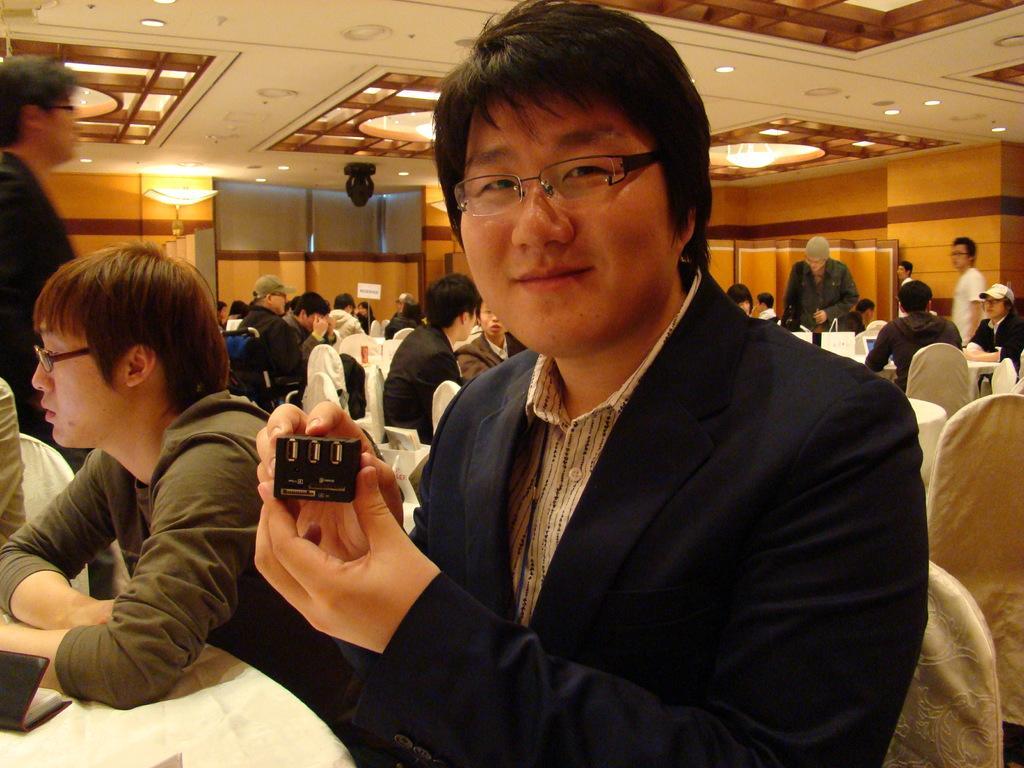In one or two sentences, can you explain what this image depicts? In the image we can see there are many people sitting and some of them are standing, they are wearing clothes and some of them are wearing spectacles and caps. Here we can see there are many chairs and tables. Here we can see a person holding an object. We can even see there are lights and the wall. 